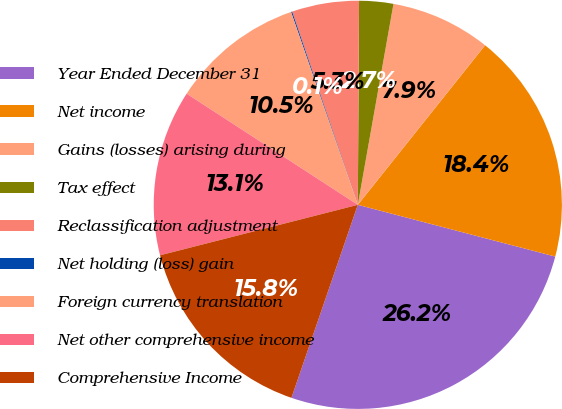Convert chart to OTSL. <chart><loc_0><loc_0><loc_500><loc_500><pie_chart><fcel>Year Ended December 31<fcel>Net income<fcel>Gains (losses) arising during<fcel>Tax effect<fcel>Reclassification adjustment<fcel>Net holding (loss) gain<fcel>Foreign currency translation<fcel>Net other comprehensive income<fcel>Comprehensive Income<nl><fcel>26.19%<fcel>18.36%<fcel>7.92%<fcel>2.7%<fcel>5.31%<fcel>0.09%<fcel>10.53%<fcel>13.14%<fcel>15.75%<nl></chart> 